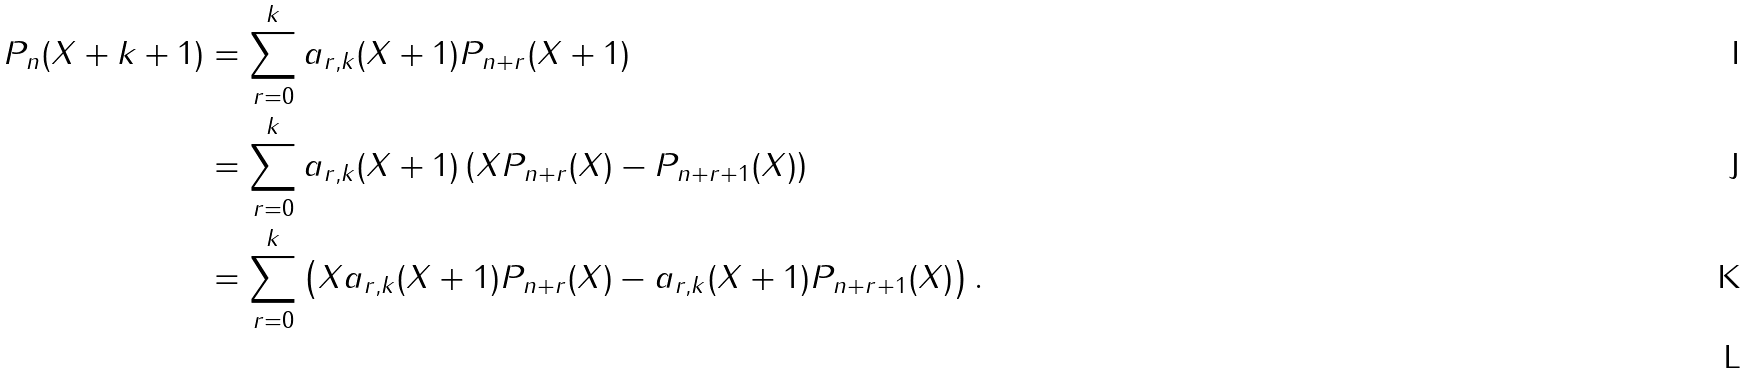Convert formula to latex. <formula><loc_0><loc_0><loc_500><loc_500>P _ { n } ( X + k + 1 ) & = \sum _ { r = 0 } ^ { k } a _ { r , k } ( X + 1 ) P _ { n + r } ( X + 1 ) \\ & = \sum _ { r = 0 } ^ { k } a _ { r , k } ( X + 1 ) \left ( X P _ { n + r } ( X ) - P _ { n + r + 1 } ( X ) \right ) \\ & = \sum _ { r = 0 } ^ { k } \left ( X a _ { r , k } ( X + 1 ) P _ { n + r } ( X ) - a _ { r , k } ( X + 1 ) P _ { n + r + 1 } ( X ) \right ) . \\</formula> 